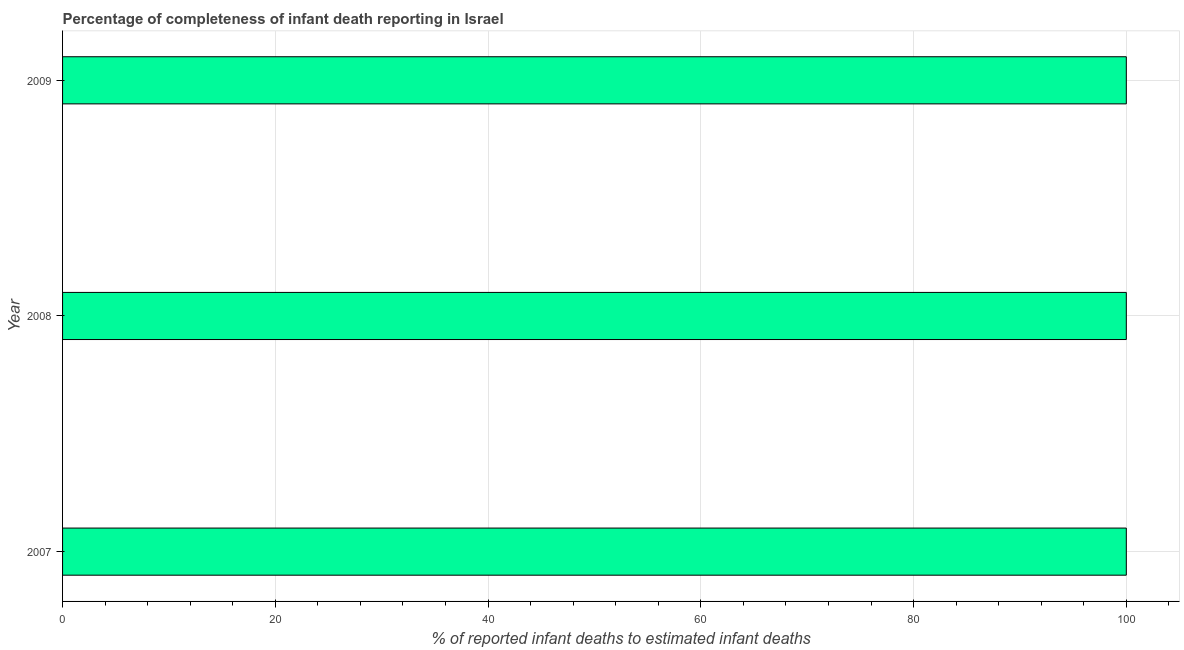Does the graph contain any zero values?
Your answer should be compact. No. What is the title of the graph?
Offer a terse response. Percentage of completeness of infant death reporting in Israel. What is the label or title of the X-axis?
Provide a succinct answer. % of reported infant deaths to estimated infant deaths. What is the label or title of the Y-axis?
Provide a short and direct response. Year. Across all years, what is the maximum completeness of infant death reporting?
Offer a terse response. 100. Across all years, what is the minimum completeness of infant death reporting?
Ensure brevity in your answer.  100. In which year was the completeness of infant death reporting maximum?
Provide a succinct answer. 2007. What is the sum of the completeness of infant death reporting?
Offer a terse response. 300. What is the median completeness of infant death reporting?
Your answer should be very brief. 100. Is the completeness of infant death reporting in 2007 less than that in 2009?
Offer a very short reply. No. What is the difference between the highest and the second highest completeness of infant death reporting?
Offer a terse response. 0. What is the difference between the highest and the lowest completeness of infant death reporting?
Your response must be concise. 0. Are all the bars in the graph horizontal?
Keep it short and to the point. Yes. How many years are there in the graph?
Give a very brief answer. 3. What is the difference between two consecutive major ticks on the X-axis?
Your answer should be very brief. 20. Are the values on the major ticks of X-axis written in scientific E-notation?
Give a very brief answer. No. What is the difference between the % of reported infant deaths to estimated infant deaths in 2007 and 2009?
Provide a short and direct response. 0. What is the difference between the % of reported infant deaths to estimated infant deaths in 2008 and 2009?
Offer a very short reply. 0. What is the ratio of the % of reported infant deaths to estimated infant deaths in 2007 to that in 2009?
Ensure brevity in your answer.  1. 